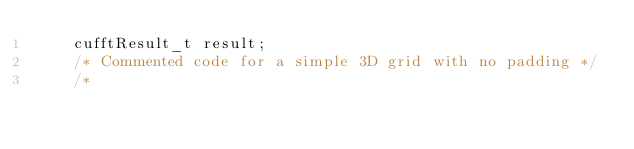<code> <loc_0><loc_0><loc_500><loc_500><_Cuda_>    cufftResult_t result;
    /* Commented code for a simple 3D grid with no padding */
    /*</code> 